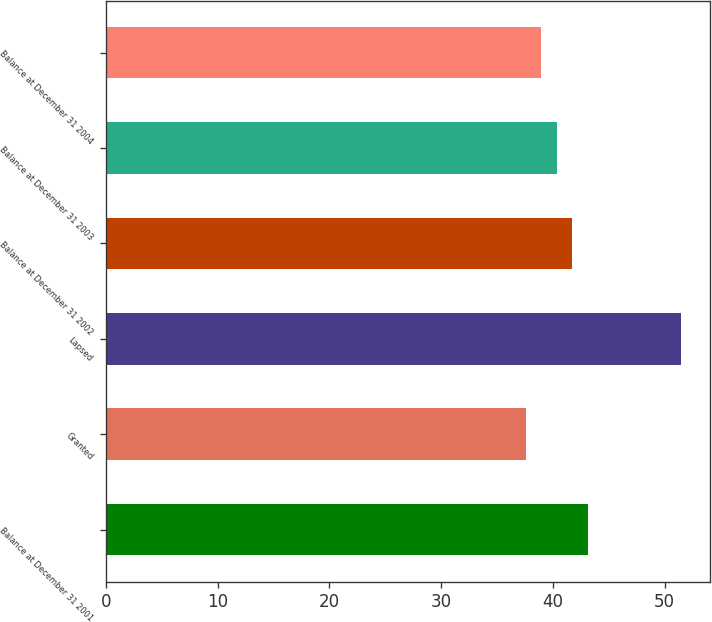<chart> <loc_0><loc_0><loc_500><loc_500><bar_chart><fcel>Balance at December 31 2001<fcel>Granted<fcel>Lapsed<fcel>Balance at December 31 2002<fcel>Balance at December 31 2003<fcel>Balance at December 31 2004<nl><fcel>43.11<fcel>37.55<fcel>51.44<fcel>41.72<fcel>40.33<fcel>38.94<nl></chart> 